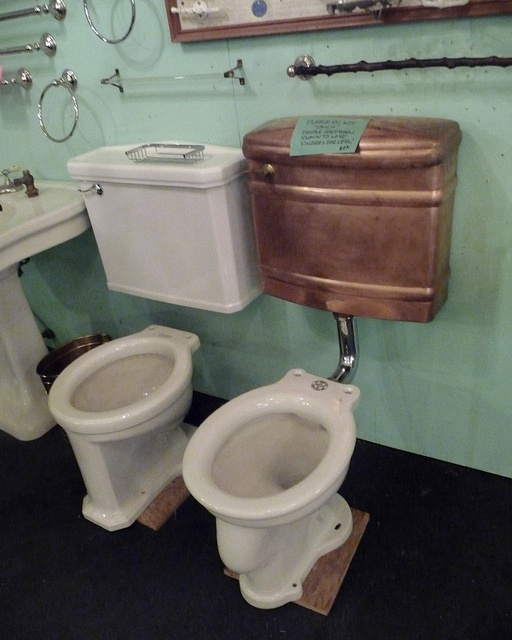Describe the objects in this image and their specific colors. I can see toilet in gray, darkgray, and maroon tones, toilet in gray and darkgray tones, and sink in gray, darkgray, and black tones in this image. 